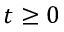<formula> <loc_0><loc_0><loc_500><loc_500>t \geq 0</formula> 